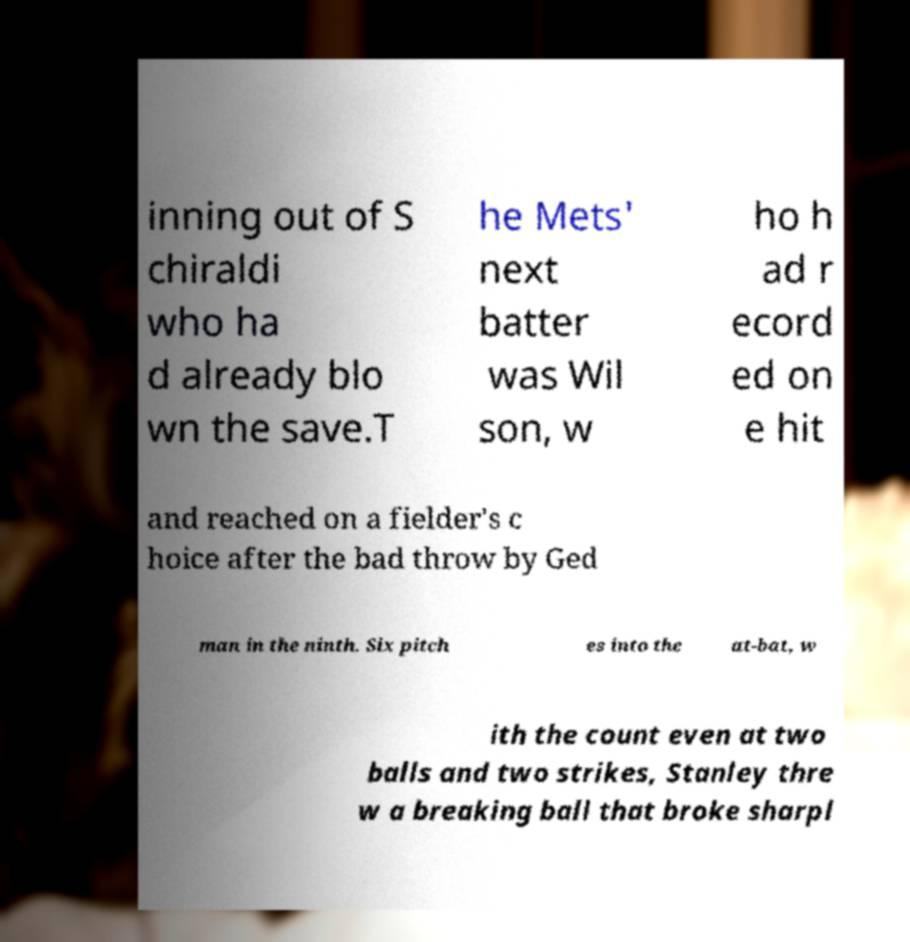Could you extract and type out the text from this image? inning out of S chiraldi who ha d already blo wn the save.T he Mets' next batter was Wil son, w ho h ad r ecord ed on e hit and reached on a fielder's c hoice after the bad throw by Ged man in the ninth. Six pitch es into the at-bat, w ith the count even at two balls and two strikes, Stanley thre w a breaking ball that broke sharpl 